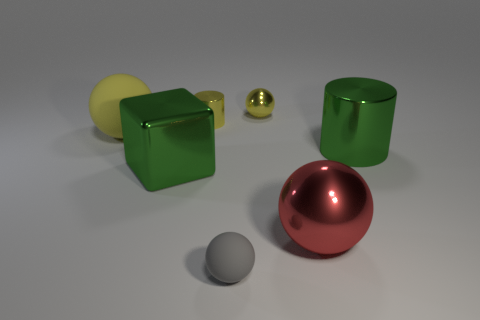Add 1 cylinders. How many objects exist? 8 Subtract all cubes. How many objects are left? 6 Subtract all yellow metal spheres. Subtract all metal cubes. How many objects are left? 5 Add 5 small gray balls. How many small gray balls are left? 6 Add 4 small yellow metal balls. How many small yellow metal balls exist? 5 Subtract 1 green cylinders. How many objects are left? 6 